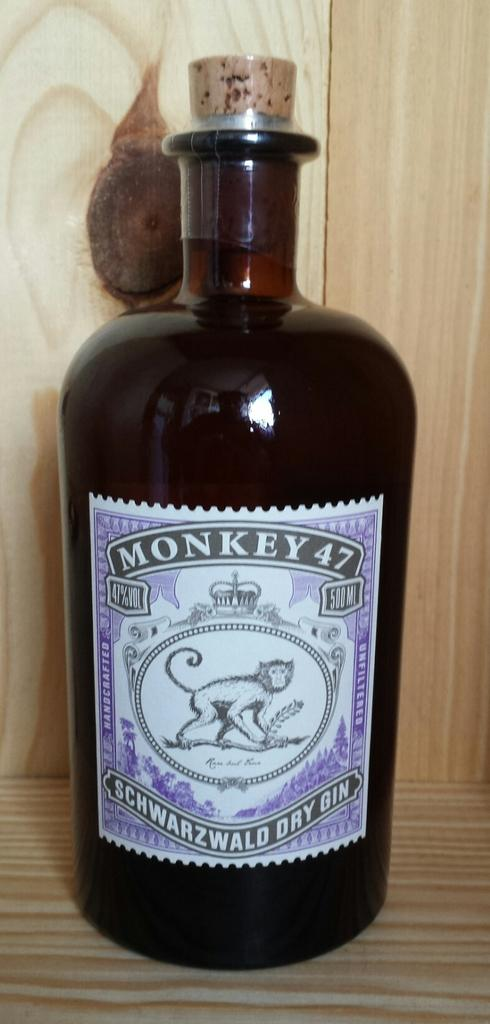<image>
Share a concise interpretation of the image provided. A bottle of Monkey 47  features a monkey on the label 